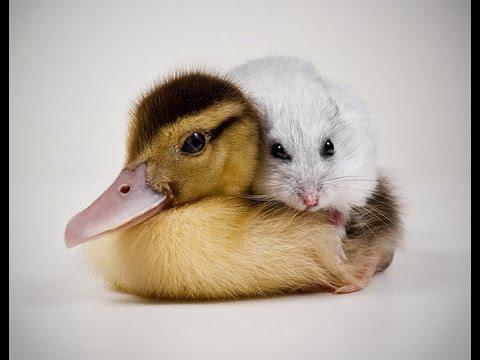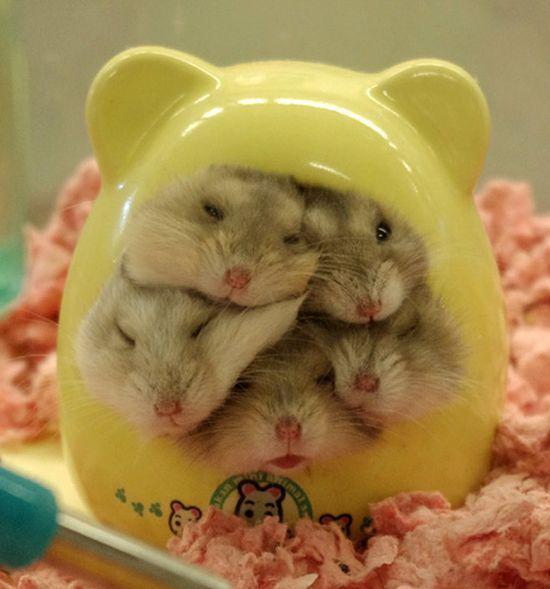The first image is the image on the left, the second image is the image on the right. Considering the images on both sides, is "There are exactly two animals." valid? Answer yes or no. No. The first image is the image on the left, the second image is the image on the right. Examine the images to the left and right. Is the description "a hamster is sitting atop draped fabric" accurate? Answer yes or no. No. 